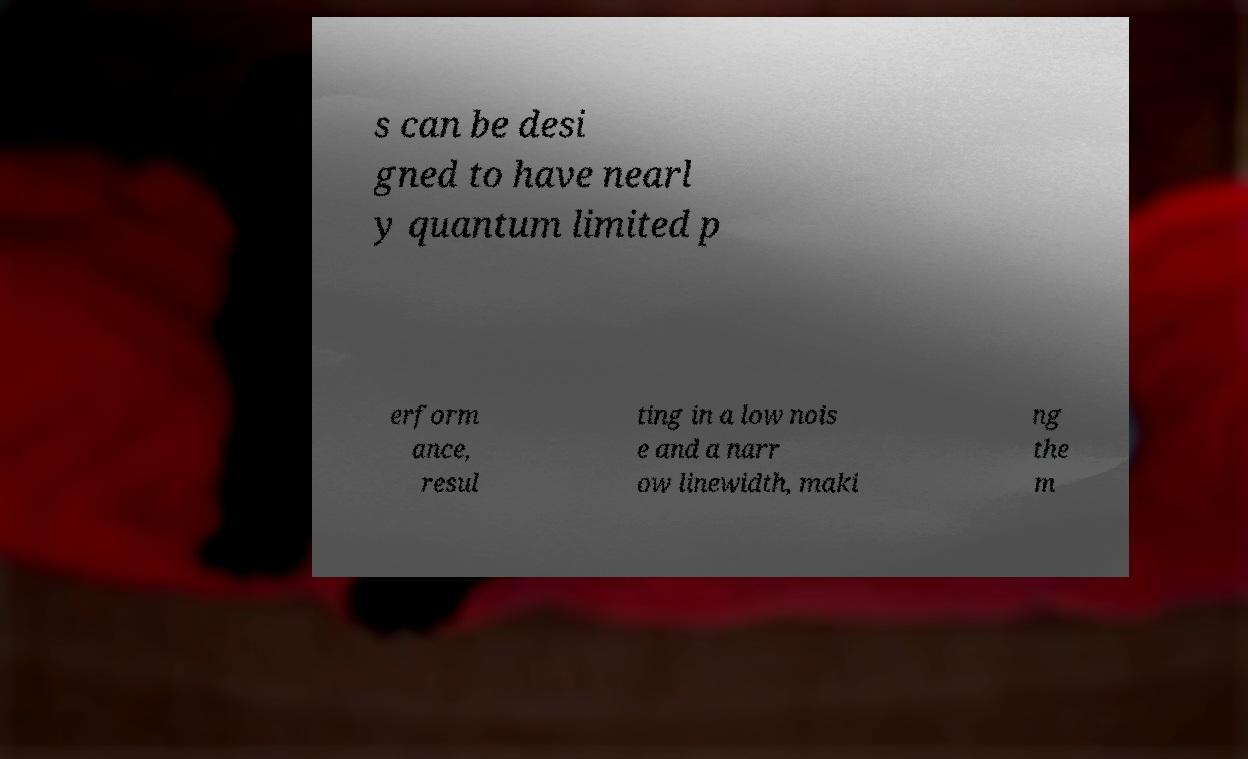For documentation purposes, I need the text within this image transcribed. Could you provide that? s can be desi gned to have nearl y quantum limited p erform ance, resul ting in a low nois e and a narr ow linewidth, maki ng the m 